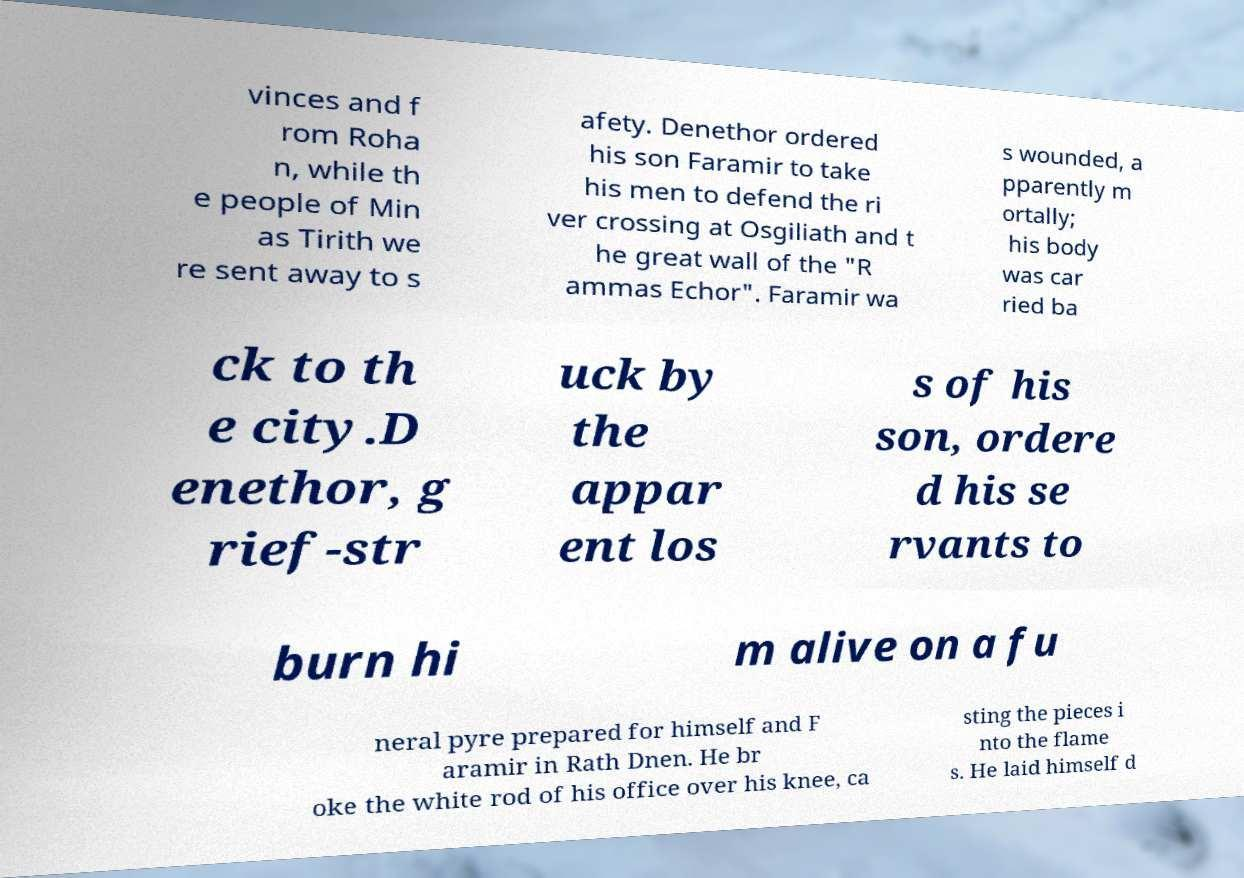Please read and relay the text visible in this image. What does it say? vinces and f rom Roha n, while th e people of Min as Tirith we re sent away to s afety. Denethor ordered his son Faramir to take his men to defend the ri ver crossing at Osgiliath and t he great wall of the "R ammas Echor". Faramir wa s wounded, a pparently m ortally; his body was car ried ba ck to th e city.D enethor, g rief-str uck by the appar ent los s of his son, ordere d his se rvants to burn hi m alive on a fu neral pyre prepared for himself and F aramir in Rath Dnen. He br oke the white rod of his office over his knee, ca sting the pieces i nto the flame s. He laid himself d 